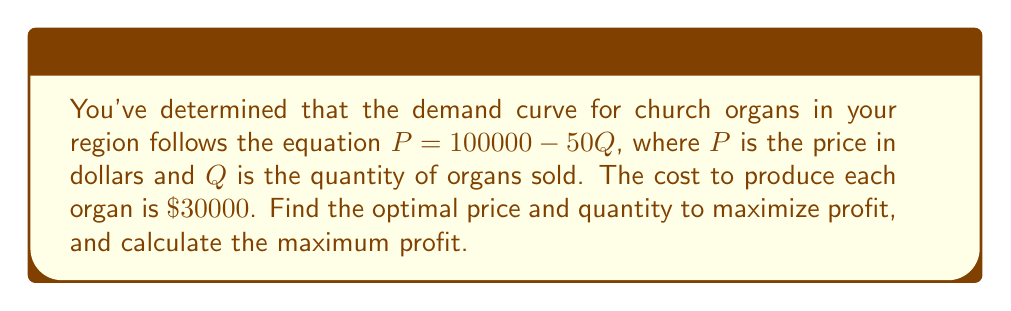Show me your answer to this math problem. To solve this problem, we'll follow these steps:

1) First, let's define the profit function. Profit is revenue minus cost:
   $\text{Profit} = \text{Revenue} - \text{Cost}$

2) Revenue is price times quantity: $PQ$
   Cost is the number of units times the cost per unit: $30000Q$

3) We can express price in terms of quantity using the demand equation:
   $P = 100000 - 50Q$

4) Now we can write the profit function in terms of Q:
   $\text{Profit} = (100000 - 50Q)Q - 30000Q$
                  $= 100000Q - 50Q^2 - 30000Q$
                  $= 70000Q - 50Q^2$

5) To find the maximum profit, we need to find where the derivative of the profit function equals zero:
   $\frac{d}{dQ}(70000Q - 50Q^2) = 70000 - 100Q$

6) Set this equal to zero and solve for Q:
   $70000 - 100Q = 0$
   $100Q = 70000$
   $Q = 700$

7) To confirm this is a maximum, we can check that the second derivative is negative:
   $\frac{d^2}{dQ^2}(70000Q - 50Q^2) = -100$, which is indeed negative.

8) Now that we know the optimal quantity, we can find the optimal price:
   $P = 100000 - 50(700) = 65000$

9) Finally, we can calculate the maximum profit:
   $\text{Profit} = 70000(700) - 50(700)^2 = 24,500,000$
Answer: The optimal price is $\$65,000$, the optimal quantity is 700 organs, and the maximum profit is $\$24,500,000$. 